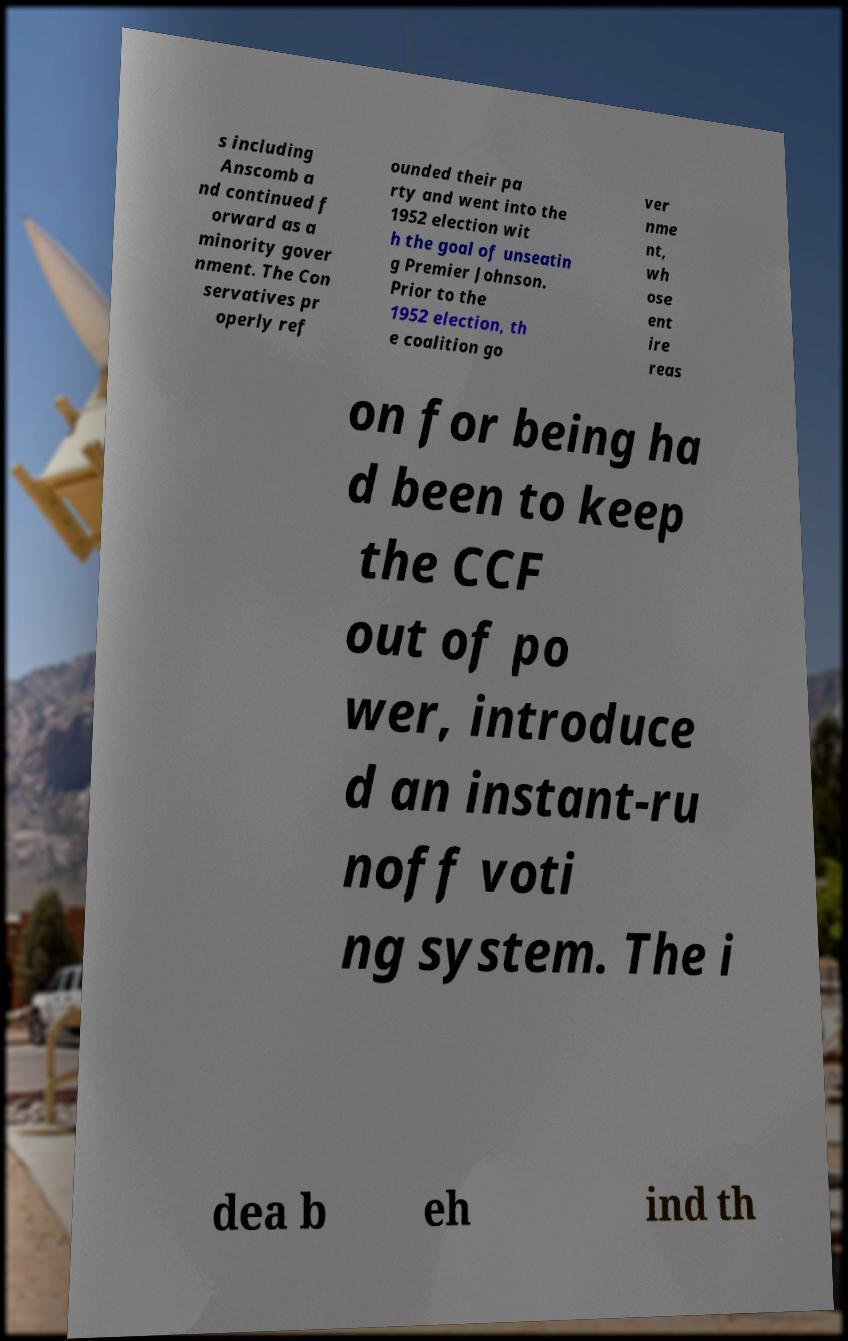I need the written content from this picture converted into text. Can you do that? s including Anscomb a nd continued f orward as a minority gover nment. The Con servatives pr operly ref ounded their pa rty and went into the 1952 election wit h the goal of unseatin g Premier Johnson. Prior to the 1952 election, th e coalition go ver nme nt, wh ose ent ire reas on for being ha d been to keep the CCF out of po wer, introduce d an instant-ru noff voti ng system. The i dea b eh ind th 